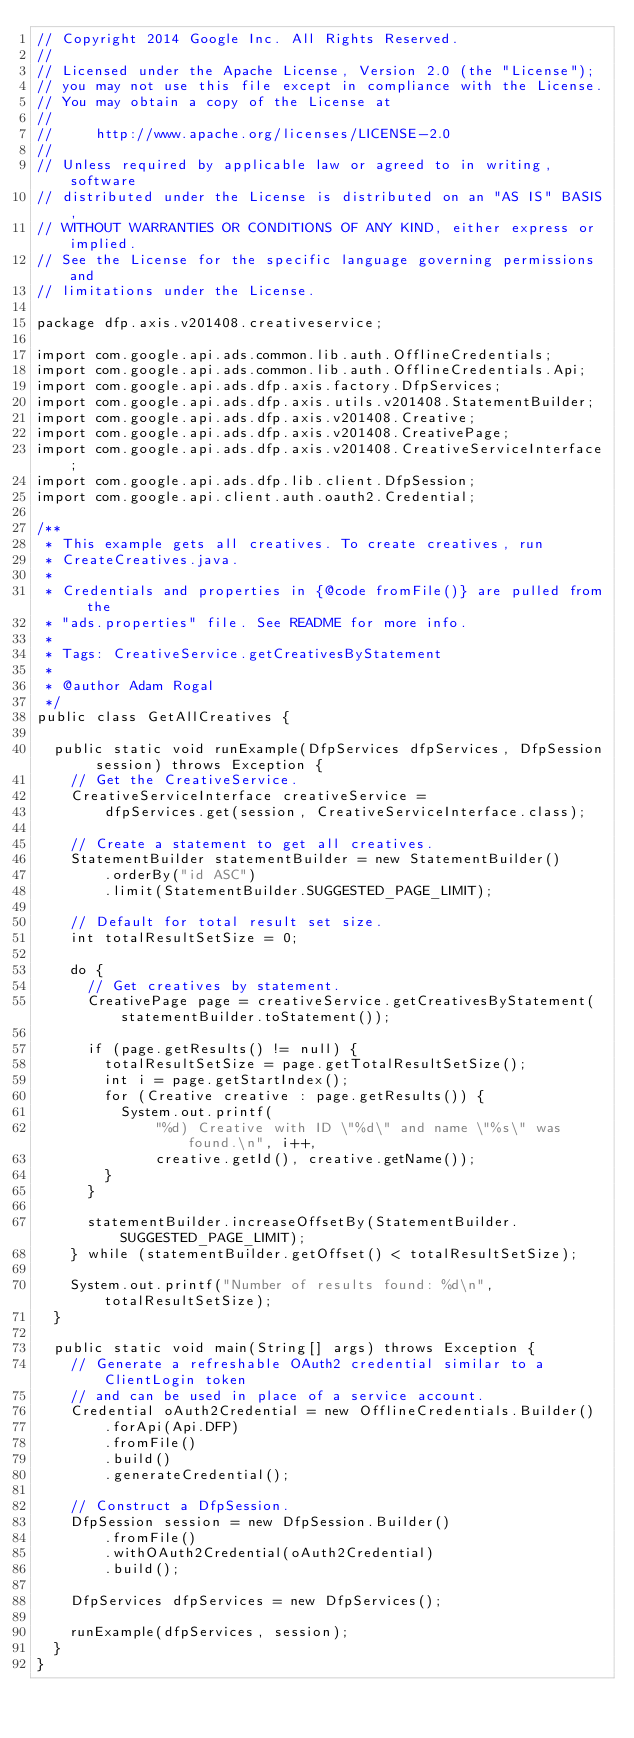Convert code to text. <code><loc_0><loc_0><loc_500><loc_500><_Java_>// Copyright 2014 Google Inc. All Rights Reserved.
//
// Licensed under the Apache License, Version 2.0 (the "License");
// you may not use this file except in compliance with the License.
// You may obtain a copy of the License at
//
//     http://www.apache.org/licenses/LICENSE-2.0
//
// Unless required by applicable law or agreed to in writing, software
// distributed under the License is distributed on an "AS IS" BASIS,
// WITHOUT WARRANTIES OR CONDITIONS OF ANY KIND, either express or implied.
// See the License for the specific language governing permissions and
// limitations under the License.

package dfp.axis.v201408.creativeservice;

import com.google.api.ads.common.lib.auth.OfflineCredentials;
import com.google.api.ads.common.lib.auth.OfflineCredentials.Api;
import com.google.api.ads.dfp.axis.factory.DfpServices;
import com.google.api.ads.dfp.axis.utils.v201408.StatementBuilder;
import com.google.api.ads.dfp.axis.v201408.Creative;
import com.google.api.ads.dfp.axis.v201408.CreativePage;
import com.google.api.ads.dfp.axis.v201408.CreativeServiceInterface;
import com.google.api.ads.dfp.lib.client.DfpSession;
import com.google.api.client.auth.oauth2.Credential;

/**
 * This example gets all creatives. To create creatives, run
 * CreateCreatives.java.
 *
 * Credentials and properties in {@code fromFile()} are pulled from the
 * "ads.properties" file. See README for more info.
 *
 * Tags: CreativeService.getCreativesByStatement
 *
 * @author Adam Rogal
 */
public class GetAllCreatives {

  public static void runExample(DfpServices dfpServices, DfpSession session) throws Exception {
    // Get the CreativeService.
    CreativeServiceInterface creativeService =
        dfpServices.get(session, CreativeServiceInterface.class);

    // Create a statement to get all creatives.
    StatementBuilder statementBuilder = new StatementBuilder()
        .orderBy("id ASC")
        .limit(StatementBuilder.SUGGESTED_PAGE_LIMIT);

    // Default for total result set size.
    int totalResultSetSize = 0;

    do {
      // Get creatives by statement.
      CreativePage page = creativeService.getCreativesByStatement(statementBuilder.toStatement());

      if (page.getResults() != null) {
        totalResultSetSize = page.getTotalResultSetSize();
        int i = page.getStartIndex();
        for (Creative creative : page.getResults()) {
          System.out.printf(
              "%d) Creative with ID \"%d\" and name \"%s\" was found.\n", i++,
              creative.getId(), creative.getName());
        }
      }

      statementBuilder.increaseOffsetBy(StatementBuilder.SUGGESTED_PAGE_LIMIT);
    } while (statementBuilder.getOffset() < totalResultSetSize);

    System.out.printf("Number of results found: %d\n", totalResultSetSize);
  }

  public static void main(String[] args) throws Exception {
    // Generate a refreshable OAuth2 credential similar to a ClientLogin token
    // and can be used in place of a service account.
    Credential oAuth2Credential = new OfflineCredentials.Builder()
        .forApi(Api.DFP)
        .fromFile()
        .build()
        .generateCredential();

    // Construct a DfpSession.
    DfpSession session = new DfpSession.Builder()
        .fromFile()
        .withOAuth2Credential(oAuth2Credential)
        .build();

    DfpServices dfpServices = new DfpServices();

    runExample(dfpServices, session);
  }
}
</code> 